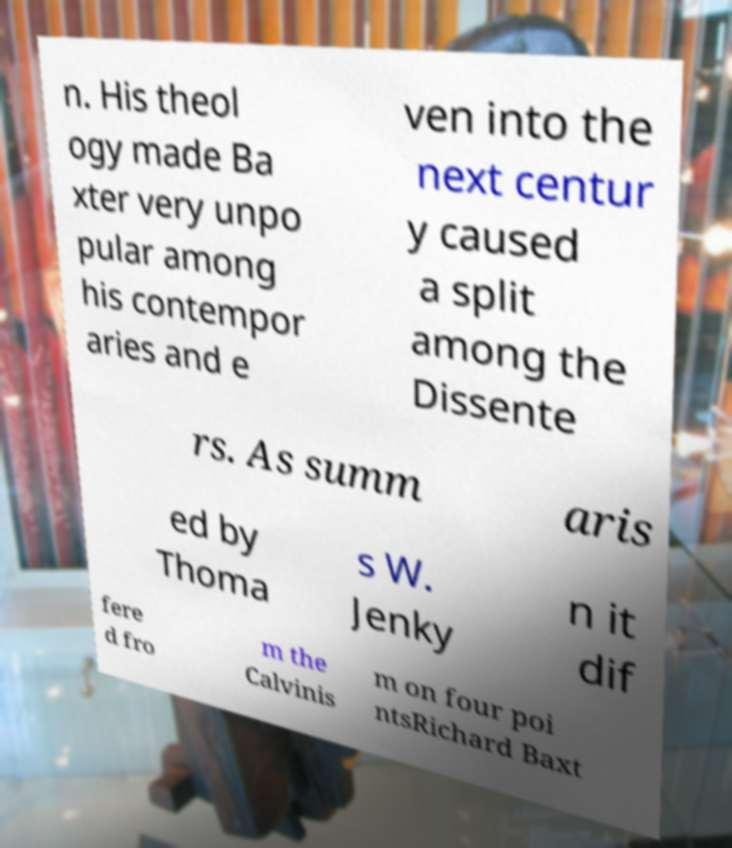Could you extract and type out the text from this image? n. His theol ogy made Ba xter very unpo pular among his contempor aries and e ven into the next centur y caused a split among the Dissente rs. As summ aris ed by Thoma s W. Jenky n it dif fere d fro m the Calvinis m on four poi ntsRichard Baxt 